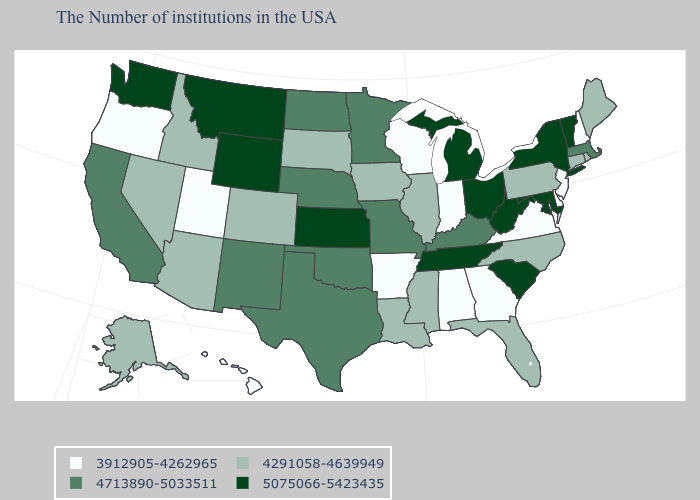What is the value of South Carolina?
Answer briefly. 5075066-5423435. Name the states that have a value in the range 4291058-4639949?
Be succinct. Maine, Rhode Island, Connecticut, Pennsylvania, North Carolina, Florida, Illinois, Mississippi, Louisiana, Iowa, South Dakota, Colorado, Arizona, Idaho, Nevada, Alaska. What is the value of New Mexico?
Answer briefly. 4713890-5033511. Name the states that have a value in the range 4291058-4639949?
Be succinct. Maine, Rhode Island, Connecticut, Pennsylvania, North Carolina, Florida, Illinois, Mississippi, Louisiana, Iowa, South Dakota, Colorado, Arizona, Idaho, Nevada, Alaska. Which states hav the highest value in the West?
Keep it brief. Wyoming, Montana, Washington. What is the value of Massachusetts?
Write a very short answer. 4713890-5033511. Name the states that have a value in the range 5075066-5423435?
Concise answer only. Vermont, New York, Maryland, South Carolina, West Virginia, Ohio, Michigan, Tennessee, Kansas, Wyoming, Montana, Washington. What is the value of Tennessee?
Write a very short answer. 5075066-5423435. Which states have the highest value in the USA?
Give a very brief answer. Vermont, New York, Maryland, South Carolina, West Virginia, Ohio, Michigan, Tennessee, Kansas, Wyoming, Montana, Washington. Does the first symbol in the legend represent the smallest category?
Quick response, please. Yes. Which states have the highest value in the USA?
Keep it brief. Vermont, New York, Maryland, South Carolina, West Virginia, Ohio, Michigan, Tennessee, Kansas, Wyoming, Montana, Washington. What is the value of Florida?
Quick response, please. 4291058-4639949. Name the states that have a value in the range 4291058-4639949?
Concise answer only. Maine, Rhode Island, Connecticut, Pennsylvania, North Carolina, Florida, Illinois, Mississippi, Louisiana, Iowa, South Dakota, Colorado, Arizona, Idaho, Nevada, Alaska. Does Alabama have the lowest value in the USA?
Quick response, please. Yes. What is the lowest value in the MidWest?
Be succinct. 3912905-4262965. 